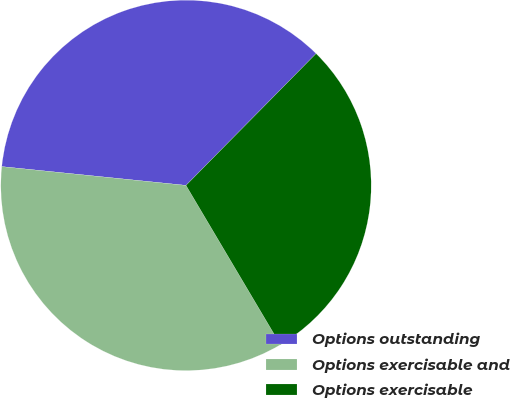Convert chart. <chart><loc_0><loc_0><loc_500><loc_500><pie_chart><fcel>Options outstanding<fcel>Options exercisable and<fcel>Options exercisable<nl><fcel>35.78%<fcel>35.13%<fcel>29.09%<nl></chart> 